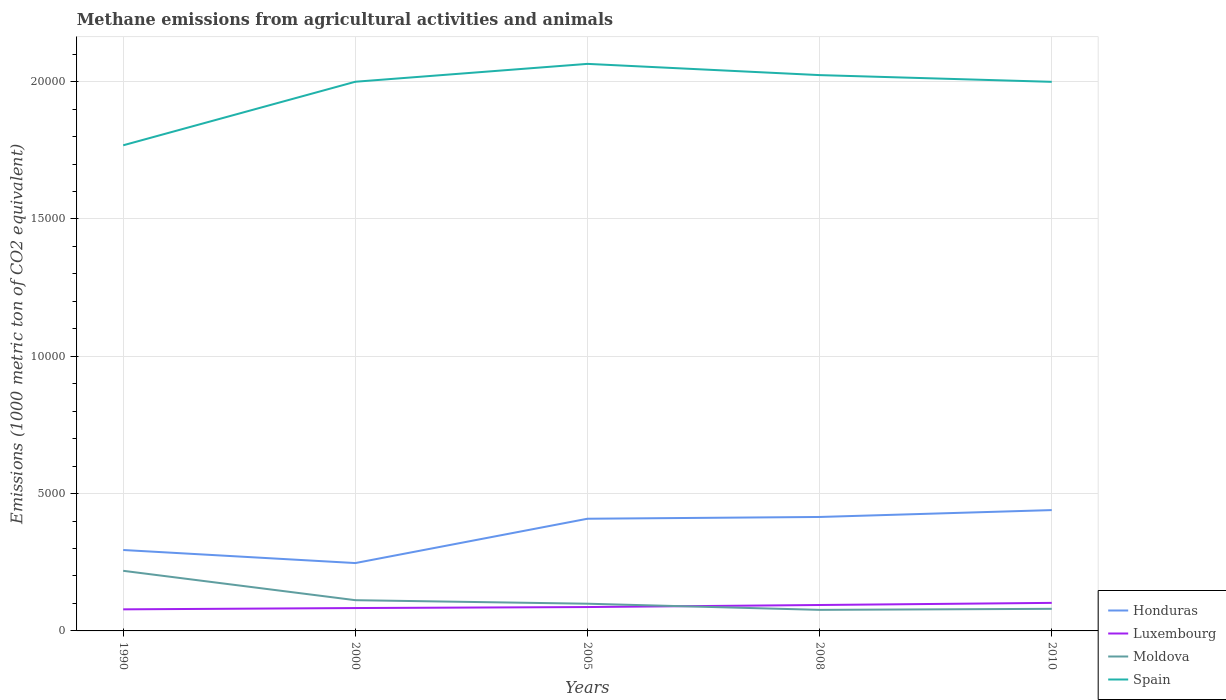How many different coloured lines are there?
Give a very brief answer. 4. Does the line corresponding to Moldova intersect with the line corresponding to Honduras?
Your answer should be compact. No. Across all years, what is the maximum amount of methane emitted in Honduras?
Keep it short and to the point. 2470.9. In which year was the amount of methane emitted in Honduras maximum?
Provide a short and direct response. 2000. What is the total amount of methane emitted in Luxembourg in the graph?
Give a very brief answer. -188.7. What is the difference between the highest and the second highest amount of methane emitted in Moldova?
Offer a terse response. 1421.7. Is the amount of methane emitted in Spain strictly greater than the amount of methane emitted in Honduras over the years?
Your answer should be very brief. No. Does the graph contain grids?
Your response must be concise. Yes. Where does the legend appear in the graph?
Offer a terse response. Bottom right. How are the legend labels stacked?
Your response must be concise. Vertical. What is the title of the graph?
Keep it short and to the point. Methane emissions from agricultural activities and animals. Does "Sub-Saharan Africa (developing only)" appear as one of the legend labels in the graph?
Provide a succinct answer. No. What is the label or title of the Y-axis?
Offer a very short reply. Emissions (1000 metric ton of CO2 equivalent). What is the Emissions (1000 metric ton of CO2 equivalent) of Honduras in 1990?
Offer a terse response. 2946.5. What is the Emissions (1000 metric ton of CO2 equivalent) of Luxembourg in 1990?
Keep it short and to the point. 785.7. What is the Emissions (1000 metric ton of CO2 equivalent) of Moldova in 1990?
Give a very brief answer. 2188.8. What is the Emissions (1000 metric ton of CO2 equivalent) in Spain in 1990?
Give a very brief answer. 1.77e+04. What is the Emissions (1000 metric ton of CO2 equivalent) in Honduras in 2000?
Make the answer very short. 2470.9. What is the Emissions (1000 metric ton of CO2 equivalent) in Luxembourg in 2000?
Make the answer very short. 832.7. What is the Emissions (1000 metric ton of CO2 equivalent) of Moldova in 2000?
Offer a very short reply. 1119.3. What is the Emissions (1000 metric ton of CO2 equivalent) in Spain in 2000?
Your response must be concise. 2.00e+04. What is the Emissions (1000 metric ton of CO2 equivalent) of Honduras in 2005?
Provide a short and direct response. 4084.8. What is the Emissions (1000 metric ton of CO2 equivalent) of Luxembourg in 2005?
Offer a very short reply. 869.4. What is the Emissions (1000 metric ton of CO2 equivalent) in Moldova in 2005?
Provide a short and direct response. 990.3. What is the Emissions (1000 metric ton of CO2 equivalent) in Spain in 2005?
Your answer should be very brief. 2.06e+04. What is the Emissions (1000 metric ton of CO2 equivalent) in Honduras in 2008?
Keep it short and to the point. 4149.3. What is the Emissions (1000 metric ton of CO2 equivalent) of Luxembourg in 2008?
Make the answer very short. 943.9. What is the Emissions (1000 metric ton of CO2 equivalent) of Moldova in 2008?
Your answer should be very brief. 767.1. What is the Emissions (1000 metric ton of CO2 equivalent) in Spain in 2008?
Offer a very short reply. 2.02e+04. What is the Emissions (1000 metric ton of CO2 equivalent) in Honduras in 2010?
Ensure brevity in your answer.  4399.5. What is the Emissions (1000 metric ton of CO2 equivalent) of Luxembourg in 2010?
Provide a succinct answer. 1021.4. What is the Emissions (1000 metric ton of CO2 equivalent) in Moldova in 2010?
Provide a short and direct response. 804.4. What is the Emissions (1000 metric ton of CO2 equivalent) in Spain in 2010?
Offer a very short reply. 2.00e+04. Across all years, what is the maximum Emissions (1000 metric ton of CO2 equivalent) in Honduras?
Your answer should be very brief. 4399.5. Across all years, what is the maximum Emissions (1000 metric ton of CO2 equivalent) in Luxembourg?
Your answer should be compact. 1021.4. Across all years, what is the maximum Emissions (1000 metric ton of CO2 equivalent) of Moldova?
Ensure brevity in your answer.  2188.8. Across all years, what is the maximum Emissions (1000 metric ton of CO2 equivalent) of Spain?
Provide a short and direct response. 2.06e+04. Across all years, what is the minimum Emissions (1000 metric ton of CO2 equivalent) of Honduras?
Your response must be concise. 2470.9. Across all years, what is the minimum Emissions (1000 metric ton of CO2 equivalent) of Luxembourg?
Your response must be concise. 785.7. Across all years, what is the minimum Emissions (1000 metric ton of CO2 equivalent) in Moldova?
Your answer should be very brief. 767.1. Across all years, what is the minimum Emissions (1000 metric ton of CO2 equivalent) of Spain?
Offer a terse response. 1.77e+04. What is the total Emissions (1000 metric ton of CO2 equivalent) in Honduras in the graph?
Provide a short and direct response. 1.81e+04. What is the total Emissions (1000 metric ton of CO2 equivalent) of Luxembourg in the graph?
Keep it short and to the point. 4453.1. What is the total Emissions (1000 metric ton of CO2 equivalent) of Moldova in the graph?
Ensure brevity in your answer.  5869.9. What is the total Emissions (1000 metric ton of CO2 equivalent) of Spain in the graph?
Give a very brief answer. 9.86e+04. What is the difference between the Emissions (1000 metric ton of CO2 equivalent) in Honduras in 1990 and that in 2000?
Provide a succinct answer. 475.6. What is the difference between the Emissions (1000 metric ton of CO2 equivalent) in Luxembourg in 1990 and that in 2000?
Offer a very short reply. -47. What is the difference between the Emissions (1000 metric ton of CO2 equivalent) in Moldova in 1990 and that in 2000?
Make the answer very short. 1069.5. What is the difference between the Emissions (1000 metric ton of CO2 equivalent) of Spain in 1990 and that in 2000?
Your response must be concise. -2314.1. What is the difference between the Emissions (1000 metric ton of CO2 equivalent) in Honduras in 1990 and that in 2005?
Ensure brevity in your answer.  -1138.3. What is the difference between the Emissions (1000 metric ton of CO2 equivalent) of Luxembourg in 1990 and that in 2005?
Keep it short and to the point. -83.7. What is the difference between the Emissions (1000 metric ton of CO2 equivalent) of Moldova in 1990 and that in 2005?
Provide a succinct answer. 1198.5. What is the difference between the Emissions (1000 metric ton of CO2 equivalent) of Spain in 1990 and that in 2005?
Keep it short and to the point. -2964.8. What is the difference between the Emissions (1000 metric ton of CO2 equivalent) of Honduras in 1990 and that in 2008?
Your answer should be very brief. -1202.8. What is the difference between the Emissions (1000 metric ton of CO2 equivalent) of Luxembourg in 1990 and that in 2008?
Provide a succinct answer. -158.2. What is the difference between the Emissions (1000 metric ton of CO2 equivalent) of Moldova in 1990 and that in 2008?
Provide a succinct answer. 1421.7. What is the difference between the Emissions (1000 metric ton of CO2 equivalent) of Spain in 1990 and that in 2008?
Ensure brevity in your answer.  -2555.9. What is the difference between the Emissions (1000 metric ton of CO2 equivalent) of Honduras in 1990 and that in 2010?
Your answer should be very brief. -1453. What is the difference between the Emissions (1000 metric ton of CO2 equivalent) in Luxembourg in 1990 and that in 2010?
Ensure brevity in your answer.  -235.7. What is the difference between the Emissions (1000 metric ton of CO2 equivalent) of Moldova in 1990 and that in 2010?
Provide a succinct answer. 1384.4. What is the difference between the Emissions (1000 metric ton of CO2 equivalent) in Spain in 1990 and that in 2010?
Ensure brevity in your answer.  -2311. What is the difference between the Emissions (1000 metric ton of CO2 equivalent) of Honduras in 2000 and that in 2005?
Make the answer very short. -1613.9. What is the difference between the Emissions (1000 metric ton of CO2 equivalent) in Luxembourg in 2000 and that in 2005?
Offer a terse response. -36.7. What is the difference between the Emissions (1000 metric ton of CO2 equivalent) of Moldova in 2000 and that in 2005?
Offer a very short reply. 129. What is the difference between the Emissions (1000 metric ton of CO2 equivalent) in Spain in 2000 and that in 2005?
Ensure brevity in your answer.  -650.7. What is the difference between the Emissions (1000 metric ton of CO2 equivalent) in Honduras in 2000 and that in 2008?
Your answer should be very brief. -1678.4. What is the difference between the Emissions (1000 metric ton of CO2 equivalent) in Luxembourg in 2000 and that in 2008?
Your answer should be very brief. -111.2. What is the difference between the Emissions (1000 metric ton of CO2 equivalent) of Moldova in 2000 and that in 2008?
Provide a succinct answer. 352.2. What is the difference between the Emissions (1000 metric ton of CO2 equivalent) of Spain in 2000 and that in 2008?
Offer a terse response. -241.8. What is the difference between the Emissions (1000 metric ton of CO2 equivalent) of Honduras in 2000 and that in 2010?
Keep it short and to the point. -1928.6. What is the difference between the Emissions (1000 metric ton of CO2 equivalent) of Luxembourg in 2000 and that in 2010?
Offer a very short reply. -188.7. What is the difference between the Emissions (1000 metric ton of CO2 equivalent) of Moldova in 2000 and that in 2010?
Provide a short and direct response. 314.9. What is the difference between the Emissions (1000 metric ton of CO2 equivalent) of Spain in 2000 and that in 2010?
Make the answer very short. 3.1. What is the difference between the Emissions (1000 metric ton of CO2 equivalent) of Honduras in 2005 and that in 2008?
Offer a terse response. -64.5. What is the difference between the Emissions (1000 metric ton of CO2 equivalent) in Luxembourg in 2005 and that in 2008?
Keep it short and to the point. -74.5. What is the difference between the Emissions (1000 metric ton of CO2 equivalent) in Moldova in 2005 and that in 2008?
Your response must be concise. 223.2. What is the difference between the Emissions (1000 metric ton of CO2 equivalent) of Spain in 2005 and that in 2008?
Your response must be concise. 408.9. What is the difference between the Emissions (1000 metric ton of CO2 equivalent) of Honduras in 2005 and that in 2010?
Your answer should be very brief. -314.7. What is the difference between the Emissions (1000 metric ton of CO2 equivalent) of Luxembourg in 2005 and that in 2010?
Provide a short and direct response. -152. What is the difference between the Emissions (1000 metric ton of CO2 equivalent) in Moldova in 2005 and that in 2010?
Your answer should be compact. 185.9. What is the difference between the Emissions (1000 metric ton of CO2 equivalent) in Spain in 2005 and that in 2010?
Your answer should be compact. 653.8. What is the difference between the Emissions (1000 metric ton of CO2 equivalent) of Honduras in 2008 and that in 2010?
Offer a very short reply. -250.2. What is the difference between the Emissions (1000 metric ton of CO2 equivalent) of Luxembourg in 2008 and that in 2010?
Ensure brevity in your answer.  -77.5. What is the difference between the Emissions (1000 metric ton of CO2 equivalent) in Moldova in 2008 and that in 2010?
Your response must be concise. -37.3. What is the difference between the Emissions (1000 metric ton of CO2 equivalent) in Spain in 2008 and that in 2010?
Offer a terse response. 244.9. What is the difference between the Emissions (1000 metric ton of CO2 equivalent) in Honduras in 1990 and the Emissions (1000 metric ton of CO2 equivalent) in Luxembourg in 2000?
Give a very brief answer. 2113.8. What is the difference between the Emissions (1000 metric ton of CO2 equivalent) in Honduras in 1990 and the Emissions (1000 metric ton of CO2 equivalent) in Moldova in 2000?
Give a very brief answer. 1827.2. What is the difference between the Emissions (1000 metric ton of CO2 equivalent) in Honduras in 1990 and the Emissions (1000 metric ton of CO2 equivalent) in Spain in 2000?
Give a very brief answer. -1.71e+04. What is the difference between the Emissions (1000 metric ton of CO2 equivalent) in Luxembourg in 1990 and the Emissions (1000 metric ton of CO2 equivalent) in Moldova in 2000?
Your response must be concise. -333.6. What is the difference between the Emissions (1000 metric ton of CO2 equivalent) in Luxembourg in 1990 and the Emissions (1000 metric ton of CO2 equivalent) in Spain in 2000?
Provide a short and direct response. -1.92e+04. What is the difference between the Emissions (1000 metric ton of CO2 equivalent) in Moldova in 1990 and the Emissions (1000 metric ton of CO2 equivalent) in Spain in 2000?
Offer a terse response. -1.78e+04. What is the difference between the Emissions (1000 metric ton of CO2 equivalent) in Honduras in 1990 and the Emissions (1000 metric ton of CO2 equivalent) in Luxembourg in 2005?
Give a very brief answer. 2077.1. What is the difference between the Emissions (1000 metric ton of CO2 equivalent) in Honduras in 1990 and the Emissions (1000 metric ton of CO2 equivalent) in Moldova in 2005?
Your answer should be very brief. 1956.2. What is the difference between the Emissions (1000 metric ton of CO2 equivalent) of Honduras in 1990 and the Emissions (1000 metric ton of CO2 equivalent) of Spain in 2005?
Ensure brevity in your answer.  -1.77e+04. What is the difference between the Emissions (1000 metric ton of CO2 equivalent) of Luxembourg in 1990 and the Emissions (1000 metric ton of CO2 equivalent) of Moldova in 2005?
Provide a succinct answer. -204.6. What is the difference between the Emissions (1000 metric ton of CO2 equivalent) in Luxembourg in 1990 and the Emissions (1000 metric ton of CO2 equivalent) in Spain in 2005?
Provide a short and direct response. -1.99e+04. What is the difference between the Emissions (1000 metric ton of CO2 equivalent) of Moldova in 1990 and the Emissions (1000 metric ton of CO2 equivalent) of Spain in 2005?
Provide a short and direct response. -1.85e+04. What is the difference between the Emissions (1000 metric ton of CO2 equivalent) of Honduras in 1990 and the Emissions (1000 metric ton of CO2 equivalent) of Luxembourg in 2008?
Offer a very short reply. 2002.6. What is the difference between the Emissions (1000 metric ton of CO2 equivalent) of Honduras in 1990 and the Emissions (1000 metric ton of CO2 equivalent) of Moldova in 2008?
Offer a terse response. 2179.4. What is the difference between the Emissions (1000 metric ton of CO2 equivalent) of Honduras in 1990 and the Emissions (1000 metric ton of CO2 equivalent) of Spain in 2008?
Make the answer very short. -1.73e+04. What is the difference between the Emissions (1000 metric ton of CO2 equivalent) of Luxembourg in 1990 and the Emissions (1000 metric ton of CO2 equivalent) of Moldova in 2008?
Your response must be concise. 18.6. What is the difference between the Emissions (1000 metric ton of CO2 equivalent) of Luxembourg in 1990 and the Emissions (1000 metric ton of CO2 equivalent) of Spain in 2008?
Provide a short and direct response. -1.95e+04. What is the difference between the Emissions (1000 metric ton of CO2 equivalent) of Moldova in 1990 and the Emissions (1000 metric ton of CO2 equivalent) of Spain in 2008?
Your answer should be compact. -1.80e+04. What is the difference between the Emissions (1000 metric ton of CO2 equivalent) of Honduras in 1990 and the Emissions (1000 metric ton of CO2 equivalent) of Luxembourg in 2010?
Offer a very short reply. 1925.1. What is the difference between the Emissions (1000 metric ton of CO2 equivalent) of Honduras in 1990 and the Emissions (1000 metric ton of CO2 equivalent) of Moldova in 2010?
Give a very brief answer. 2142.1. What is the difference between the Emissions (1000 metric ton of CO2 equivalent) in Honduras in 1990 and the Emissions (1000 metric ton of CO2 equivalent) in Spain in 2010?
Provide a short and direct response. -1.70e+04. What is the difference between the Emissions (1000 metric ton of CO2 equivalent) of Luxembourg in 1990 and the Emissions (1000 metric ton of CO2 equivalent) of Moldova in 2010?
Offer a very short reply. -18.7. What is the difference between the Emissions (1000 metric ton of CO2 equivalent) of Luxembourg in 1990 and the Emissions (1000 metric ton of CO2 equivalent) of Spain in 2010?
Your response must be concise. -1.92e+04. What is the difference between the Emissions (1000 metric ton of CO2 equivalent) in Moldova in 1990 and the Emissions (1000 metric ton of CO2 equivalent) in Spain in 2010?
Your response must be concise. -1.78e+04. What is the difference between the Emissions (1000 metric ton of CO2 equivalent) in Honduras in 2000 and the Emissions (1000 metric ton of CO2 equivalent) in Luxembourg in 2005?
Your answer should be compact. 1601.5. What is the difference between the Emissions (1000 metric ton of CO2 equivalent) in Honduras in 2000 and the Emissions (1000 metric ton of CO2 equivalent) in Moldova in 2005?
Keep it short and to the point. 1480.6. What is the difference between the Emissions (1000 metric ton of CO2 equivalent) of Honduras in 2000 and the Emissions (1000 metric ton of CO2 equivalent) of Spain in 2005?
Your answer should be very brief. -1.82e+04. What is the difference between the Emissions (1000 metric ton of CO2 equivalent) in Luxembourg in 2000 and the Emissions (1000 metric ton of CO2 equivalent) in Moldova in 2005?
Ensure brevity in your answer.  -157.6. What is the difference between the Emissions (1000 metric ton of CO2 equivalent) of Luxembourg in 2000 and the Emissions (1000 metric ton of CO2 equivalent) of Spain in 2005?
Give a very brief answer. -1.98e+04. What is the difference between the Emissions (1000 metric ton of CO2 equivalent) of Moldova in 2000 and the Emissions (1000 metric ton of CO2 equivalent) of Spain in 2005?
Your response must be concise. -1.95e+04. What is the difference between the Emissions (1000 metric ton of CO2 equivalent) of Honduras in 2000 and the Emissions (1000 metric ton of CO2 equivalent) of Luxembourg in 2008?
Provide a short and direct response. 1527. What is the difference between the Emissions (1000 metric ton of CO2 equivalent) of Honduras in 2000 and the Emissions (1000 metric ton of CO2 equivalent) of Moldova in 2008?
Keep it short and to the point. 1703.8. What is the difference between the Emissions (1000 metric ton of CO2 equivalent) in Honduras in 2000 and the Emissions (1000 metric ton of CO2 equivalent) in Spain in 2008?
Provide a succinct answer. -1.78e+04. What is the difference between the Emissions (1000 metric ton of CO2 equivalent) in Luxembourg in 2000 and the Emissions (1000 metric ton of CO2 equivalent) in Moldova in 2008?
Give a very brief answer. 65.6. What is the difference between the Emissions (1000 metric ton of CO2 equivalent) of Luxembourg in 2000 and the Emissions (1000 metric ton of CO2 equivalent) of Spain in 2008?
Provide a short and direct response. -1.94e+04. What is the difference between the Emissions (1000 metric ton of CO2 equivalent) in Moldova in 2000 and the Emissions (1000 metric ton of CO2 equivalent) in Spain in 2008?
Your response must be concise. -1.91e+04. What is the difference between the Emissions (1000 metric ton of CO2 equivalent) in Honduras in 2000 and the Emissions (1000 metric ton of CO2 equivalent) in Luxembourg in 2010?
Offer a terse response. 1449.5. What is the difference between the Emissions (1000 metric ton of CO2 equivalent) in Honduras in 2000 and the Emissions (1000 metric ton of CO2 equivalent) in Moldova in 2010?
Your answer should be very brief. 1666.5. What is the difference between the Emissions (1000 metric ton of CO2 equivalent) in Honduras in 2000 and the Emissions (1000 metric ton of CO2 equivalent) in Spain in 2010?
Make the answer very short. -1.75e+04. What is the difference between the Emissions (1000 metric ton of CO2 equivalent) of Luxembourg in 2000 and the Emissions (1000 metric ton of CO2 equivalent) of Moldova in 2010?
Your response must be concise. 28.3. What is the difference between the Emissions (1000 metric ton of CO2 equivalent) of Luxembourg in 2000 and the Emissions (1000 metric ton of CO2 equivalent) of Spain in 2010?
Your response must be concise. -1.92e+04. What is the difference between the Emissions (1000 metric ton of CO2 equivalent) of Moldova in 2000 and the Emissions (1000 metric ton of CO2 equivalent) of Spain in 2010?
Keep it short and to the point. -1.89e+04. What is the difference between the Emissions (1000 metric ton of CO2 equivalent) of Honduras in 2005 and the Emissions (1000 metric ton of CO2 equivalent) of Luxembourg in 2008?
Provide a short and direct response. 3140.9. What is the difference between the Emissions (1000 metric ton of CO2 equivalent) of Honduras in 2005 and the Emissions (1000 metric ton of CO2 equivalent) of Moldova in 2008?
Ensure brevity in your answer.  3317.7. What is the difference between the Emissions (1000 metric ton of CO2 equivalent) of Honduras in 2005 and the Emissions (1000 metric ton of CO2 equivalent) of Spain in 2008?
Provide a short and direct response. -1.62e+04. What is the difference between the Emissions (1000 metric ton of CO2 equivalent) in Luxembourg in 2005 and the Emissions (1000 metric ton of CO2 equivalent) in Moldova in 2008?
Provide a short and direct response. 102.3. What is the difference between the Emissions (1000 metric ton of CO2 equivalent) in Luxembourg in 2005 and the Emissions (1000 metric ton of CO2 equivalent) in Spain in 2008?
Provide a short and direct response. -1.94e+04. What is the difference between the Emissions (1000 metric ton of CO2 equivalent) of Moldova in 2005 and the Emissions (1000 metric ton of CO2 equivalent) of Spain in 2008?
Keep it short and to the point. -1.92e+04. What is the difference between the Emissions (1000 metric ton of CO2 equivalent) of Honduras in 2005 and the Emissions (1000 metric ton of CO2 equivalent) of Luxembourg in 2010?
Give a very brief answer. 3063.4. What is the difference between the Emissions (1000 metric ton of CO2 equivalent) of Honduras in 2005 and the Emissions (1000 metric ton of CO2 equivalent) of Moldova in 2010?
Your answer should be compact. 3280.4. What is the difference between the Emissions (1000 metric ton of CO2 equivalent) of Honduras in 2005 and the Emissions (1000 metric ton of CO2 equivalent) of Spain in 2010?
Offer a very short reply. -1.59e+04. What is the difference between the Emissions (1000 metric ton of CO2 equivalent) of Luxembourg in 2005 and the Emissions (1000 metric ton of CO2 equivalent) of Moldova in 2010?
Your answer should be compact. 65. What is the difference between the Emissions (1000 metric ton of CO2 equivalent) of Luxembourg in 2005 and the Emissions (1000 metric ton of CO2 equivalent) of Spain in 2010?
Give a very brief answer. -1.91e+04. What is the difference between the Emissions (1000 metric ton of CO2 equivalent) of Moldova in 2005 and the Emissions (1000 metric ton of CO2 equivalent) of Spain in 2010?
Provide a short and direct response. -1.90e+04. What is the difference between the Emissions (1000 metric ton of CO2 equivalent) in Honduras in 2008 and the Emissions (1000 metric ton of CO2 equivalent) in Luxembourg in 2010?
Offer a very short reply. 3127.9. What is the difference between the Emissions (1000 metric ton of CO2 equivalent) of Honduras in 2008 and the Emissions (1000 metric ton of CO2 equivalent) of Moldova in 2010?
Keep it short and to the point. 3344.9. What is the difference between the Emissions (1000 metric ton of CO2 equivalent) of Honduras in 2008 and the Emissions (1000 metric ton of CO2 equivalent) of Spain in 2010?
Your response must be concise. -1.58e+04. What is the difference between the Emissions (1000 metric ton of CO2 equivalent) in Luxembourg in 2008 and the Emissions (1000 metric ton of CO2 equivalent) in Moldova in 2010?
Keep it short and to the point. 139.5. What is the difference between the Emissions (1000 metric ton of CO2 equivalent) of Luxembourg in 2008 and the Emissions (1000 metric ton of CO2 equivalent) of Spain in 2010?
Give a very brief answer. -1.90e+04. What is the difference between the Emissions (1000 metric ton of CO2 equivalent) of Moldova in 2008 and the Emissions (1000 metric ton of CO2 equivalent) of Spain in 2010?
Your answer should be very brief. -1.92e+04. What is the average Emissions (1000 metric ton of CO2 equivalent) in Honduras per year?
Your answer should be very brief. 3610.2. What is the average Emissions (1000 metric ton of CO2 equivalent) of Luxembourg per year?
Your answer should be very brief. 890.62. What is the average Emissions (1000 metric ton of CO2 equivalent) in Moldova per year?
Provide a short and direct response. 1173.98. What is the average Emissions (1000 metric ton of CO2 equivalent) in Spain per year?
Offer a terse response. 1.97e+04. In the year 1990, what is the difference between the Emissions (1000 metric ton of CO2 equivalent) in Honduras and Emissions (1000 metric ton of CO2 equivalent) in Luxembourg?
Your answer should be very brief. 2160.8. In the year 1990, what is the difference between the Emissions (1000 metric ton of CO2 equivalent) in Honduras and Emissions (1000 metric ton of CO2 equivalent) in Moldova?
Your answer should be compact. 757.7. In the year 1990, what is the difference between the Emissions (1000 metric ton of CO2 equivalent) in Honduras and Emissions (1000 metric ton of CO2 equivalent) in Spain?
Provide a succinct answer. -1.47e+04. In the year 1990, what is the difference between the Emissions (1000 metric ton of CO2 equivalent) of Luxembourg and Emissions (1000 metric ton of CO2 equivalent) of Moldova?
Give a very brief answer. -1403.1. In the year 1990, what is the difference between the Emissions (1000 metric ton of CO2 equivalent) in Luxembourg and Emissions (1000 metric ton of CO2 equivalent) in Spain?
Offer a very short reply. -1.69e+04. In the year 1990, what is the difference between the Emissions (1000 metric ton of CO2 equivalent) of Moldova and Emissions (1000 metric ton of CO2 equivalent) of Spain?
Give a very brief answer. -1.55e+04. In the year 2000, what is the difference between the Emissions (1000 metric ton of CO2 equivalent) in Honduras and Emissions (1000 metric ton of CO2 equivalent) in Luxembourg?
Offer a terse response. 1638.2. In the year 2000, what is the difference between the Emissions (1000 metric ton of CO2 equivalent) of Honduras and Emissions (1000 metric ton of CO2 equivalent) of Moldova?
Ensure brevity in your answer.  1351.6. In the year 2000, what is the difference between the Emissions (1000 metric ton of CO2 equivalent) of Honduras and Emissions (1000 metric ton of CO2 equivalent) of Spain?
Give a very brief answer. -1.75e+04. In the year 2000, what is the difference between the Emissions (1000 metric ton of CO2 equivalent) of Luxembourg and Emissions (1000 metric ton of CO2 equivalent) of Moldova?
Your answer should be very brief. -286.6. In the year 2000, what is the difference between the Emissions (1000 metric ton of CO2 equivalent) in Luxembourg and Emissions (1000 metric ton of CO2 equivalent) in Spain?
Make the answer very short. -1.92e+04. In the year 2000, what is the difference between the Emissions (1000 metric ton of CO2 equivalent) in Moldova and Emissions (1000 metric ton of CO2 equivalent) in Spain?
Ensure brevity in your answer.  -1.89e+04. In the year 2005, what is the difference between the Emissions (1000 metric ton of CO2 equivalent) in Honduras and Emissions (1000 metric ton of CO2 equivalent) in Luxembourg?
Your answer should be compact. 3215.4. In the year 2005, what is the difference between the Emissions (1000 metric ton of CO2 equivalent) of Honduras and Emissions (1000 metric ton of CO2 equivalent) of Moldova?
Keep it short and to the point. 3094.5. In the year 2005, what is the difference between the Emissions (1000 metric ton of CO2 equivalent) of Honduras and Emissions (1000 metric ton of CO2 equivalent) of Spain?
Provide a short and direct response. -1.66e+04. In the year 2005, what is the difference between the Emissions (1000 metric ton of CO2 equivalent) of Luxembourg and Emissions (1000 metric ton of CO2 equivalent) of Moldova?
Offer a very short reply. -120.9. In the year 2005, what is the difference between the Emissions (1000 metric ton of CO2 equivalent) in Luxembourg and Emissions (1000 metric ton of CO2 equivalent) in Spain?
Give a very brief answer. -1.98e+04. In the year 2005, what is the difference between the Emissions (1000 metric ton of CO2 equivalent) of Moldova and Emissions (1000 metric ton of CO2 equivalent) of Spain?
Keep it short and to the point. -1.97e+04. In the year 2008, what is the difference between the Emissions (1000 metric ton of CO2 equivalent) of Honduras and Emissions (1000 metric ton of CO2 equivalent) of Luxembourg?
Offer a very short reply. 3205.4. In the year 2008, what is the difference between the Emissions (1000 metric ton of CO2 equivalent) in Honduras and Emissions (1000 metric ton of CO2 equivalent) in Moldova?
Offer a very short reply. 3382.2. In the year 2008, what is the difference between the Emissions (1000 metric ton of CO2 equivalent) of Honduras and Emissions (1000 metric ton of CO2 equivalent) of Spain?
Keep it short and to the point. -1.61e+04. In the year 2008, what is the difference between the Emissions (1000 metric ton of CO2 equivalent) of Luxembourg and Emissions (1000 metric ton of CO2 equivalent) of Moldova?
Your response must be concise. 176.8. In the year 2008, what is the difference between the Emissions (1000 metric ton of CO2 equivalent) of Luxembourg and Emissions (1000 metric ton of CO2 equivalent) of Spain?
Keep it short and to the point. -1.93e+04. In the year 2008, what is the difference between the Emissions (1000 metric ton of CO2 equivalent) of Moldova and Emissions (1000 metric ton of CO2 equivalent) of Spain?
Provide a succinct answer. -1.95e+04. In the year 2010, what is the difference between the Emissions (1000 metric ton of CO2 equivalent) in Honduras and Emissions (1000 metric ton of CO2 equivalent) in Luxembourg?
Keep it short and to the point. 3378.1. In the year 2010, what is the difference between the Emissions (1000 metric ton of CO2 equivalent) in Honduras and Emissions (1000 metric ton of CO2 equivalent) in Moldova?
Provide a short and direct response. 3595.1. In the year 2010, what is the difference between the Emissions (1000 metric ton of CO2 equivalent) in Honduras and Emissions (1000 metric ton of CO2 equivalent) in Spain?
Provide a succinct answer. -1.56e+04. In the year 2010, what is the difference between the Emissions (1000 metric ton of CO2 equivalent) in Luxembourg and Emissions (1000 metric ton of CO2 equivalent) in Moldova?
Your response must be concise. 217. In the year 2010, what is the difference between the Emissions (1000 metric ton of CO2 equivalent) of Luxembourg and Emissions (1000 metric ton of CO2 equivalent) of Spain?
Ensure brevity in your answer.  -1.90e+04. In the year 2010, what is the difference between the Emissions (1000 metric ton of CO2 equivalent) of Moldova and Emissions (1000 metric ton of CO2 equivalent) of Spain?
Your answer should be compact. -1.92e+04. What is the ratio of the Emissions (1000 metric ton of CO2 equivalent) in Honduras in 1990 to that in 2000?
Your answer should be compact. 1.19. What is the ratio of the Emissions (1000 metric ton of CO2 equivalent) of Luxembourg in 1990 to that in 2000?
Offer a very short reply. 0.94. What is the ratio of the Emissions (1000 metric ton of CO2 equivalent) of Moldova in 1990 to that in 2000?
Keep it short and to the point. 1.96. What is the ratio of the Emissions (1000 metric ton of CO2 equivalent) in Spain in 1990 to that in 2000?
Offer a terse response. 0.88. What is the ratio of the Emissions (1000 metric ton of CO2 equivalent) of Honduras in 1990 to that in 2005?
Offer a very short reply. 0.72. What is the ratio of the Emissions (1000 metric ton of CO2 equivalent) of Luxembourg in 1990 to that in 2005?
Provide a short and direct response. 0.9. What is the ratio of the Emissions (1000 metric ton of CO2 equivalent) of Moldova in 1990 to that in 2005?
Offer a terse response. 2.21. What is the ratio of the Emissions (1000 metric ton of CO2 equivalent) in Spain in 1990 to that in 2005?
Your answer should be compact. 0.86. What is the ratio of the Emissions (1000 metric ton of CO2 equivalent) in Honduras in 1990 to that in 2008?
Provide a short and direct response. 0.71. What is the ratio of the Emissions (1000 metric ton of CO2 equivalent) in Luxembourg in 1990 to that in 2008?
Offer a terse response. 0.83. What is the ratio of the Emissions (1000 metric ton of CO2 equivalent) in Moldova in 1990 to that in 2008?
Keep it short and to the point. 2.85. What is the ratio of the Emissions (1000 metric ton of CO2 equivalent) of Spain in 1990 to that in 2008?
Give a very brief answer. 0.87. What is the ratio of the Emissions (1000 metric ton of CO2 equivalent) in Honduras in 1990 to that in 2010?
Your response must be concise. 0.67. What is the ratio of the Emissions (1000 metric ton of CO2 equivalent) of Luxembourg in 1990 to that in 2010?
Make the answer very short. 0.77. What is the ratio of the Emissions (1000 metric ton of CO2 equivalent) in Moldova in 1990 to that in 2010?
Give a very brief answer. 2.72. What is the ratio of the Emissions (1000 metric ton of CO2 equivalent) in Spain in 1990 to that in 2010?
Offer a terse response. 0.88. What is the ratio of the Emissions (1000 metric ton of CO2 equivalent) in Honduras in 2000 to that in 2005?
Your answer should be very brief. 0.6. What is the ratio of the Emissions (1000 metric ton of CO2 equivalent) in Luxembourg in 2000 to that in 2005?
Offer a very short reply. 0.96. What is the ratio of the Emissions (1000 metric ton of CO2 equivalent) in Moldova in 2000 to that in 2005?
Offer a very short reply. 1.13. What is the ratio of the Emissions (1000 metric ton of CO2 equivalent) in Spain in 2000 to that in 2005?
Your answer should be very brief. 0.97. What is the ratio of the Emissions (1000 metric ton of CO2 equivalent) in Honduras in 2000 to that in 2008?
Your response must be concise. 0.6. What is the ratio of the Emissions (1000 metric ton of CO2 equivalent) in Luxembourg in 2000 to that in 2008?
Keep it short and to the point. 0.88. What is the ratio of the Emissions (1000 metric ton of CO2 equivalent) of Moldova in 2000 to that in 2008?
Offer a terse response. 1.46. What is the ratio of the Emissions (1000 metric ton of CO2 equivalent) in Honduras in 2000 to that in 2010?
Your answer should be compact. 0.56. What is the ratio of the Emissions (1000 metric ton of CO2 equivalent) in Luxembourg in 2000 to that in 2010?
Your answer should be very brief. 0.82. What is the ratio of the Emissions (1000 metric ton of CO2 equivalent) of Moldova in 2000 to that in 2010?
Keep it short and to the point. 1.39. What is the ratio of the Emissions (1000 metric ton of CO2 equivalent) in Honduras in 2005 to that in 2008?
Your response must be concise. 0.98. What is the ratio of the Emissions (1000 metric ton of CO2 equivalent) of Luxembourg in 2005 to that in 2008?
Provide a short and direct response. 0.92. What is the ratio of the Emissions (1000 metric ton of CO2 equivalent) in Moldova in 2005 to that in 2008?
Your response must be concise. 1.29. What is the ratio of the Emissions (1000 metric ton of CO2 equivalent) of Spain in 2005 to that in 2008?
Your response must be concise. 1.02. What is the ratio of the Emissions (1000 metric ton of CO2 equivalent) in Honduras in 2005 to that in 2010?
Provide a succinct answer. 0.93. What is the ratio of the Emissions (1000 metric ton of CO2 equivalent) of Luxembourg in 2005 to that in 2010?
Keep it short and to the point. 0.85. What is the ratio of the Emissions (1000 metric ton of CO2 equivalent) in Moldova in 2005 to that in 2010?
Your answer should be compact. 1.23. What is the ratio of the Emissions (1000 metric ton of CO2 equivalent) of Spain in 2005 to that in 2010?
Provide a short and direct response. 1.03. What is the ratio of the Emissions (1000 metric ton of CO2 equivalent) of Honduras in 2008 to that in 2010?
Offer a terse response. 0.94. What is the ratio of the Emissions (1000 metric ton of CO2 equivalent) in Luxembourg in 2008 to that in 2010?
Give a very brief answer. 0.92. What is the ratio of the Emissions (1000 metric ton of CO2 equivalent) in Moldova in 2008 to that in 2010?
Ensure brevity in your answer.  0.95. What is the ratio of the Emissions (1000 metric ton of CO2 equivalent) of Spain in 2008 to that in 2010?
Make the answer very short. 1.01. What is the difference between the highest and the second highest Emissions (1000 metric ton of CO2 equivalent) of Honduras?
Provide a short and direct response. 250.2. What is the difference between the highest and the second highest Emissions (1000 metric ton of CO2 equivalent) in Luxembourg?
Give a very brief answer. 77.5. What is the difference between the highest and the second highest Emissions (1000 metric ton of CO2 equivalent) of Moldova?
Ensure brevity in your answer.  1069.5. What is the difference between the highest and the second highest Emissions (1000 metric ton of CO2 equivalent) of Spain?
Keep it short and to the point. 408.9. What is the difference between the highest and the lowest Emissions (1000 metric ton of CO2 equivalent) in Honduras?
Make the answer very short. 1928.6. What is the difference between the highest and the lowest Emissions (1000 metric ton of CO2 equivalent) of Luxembourg?
Ensure brevity in your answer.  235.7. What is the difference between the highest and the lowest Emissions (1000 metric ton of CO2 equivalent) of Moldova?
Your answer should be compact. 1421.7. What is the difference between the highest and the lowest Emissions (1000 metric ton of CO2 equivalent) in Spain?
Your answer should be very brief. 2964.8. 